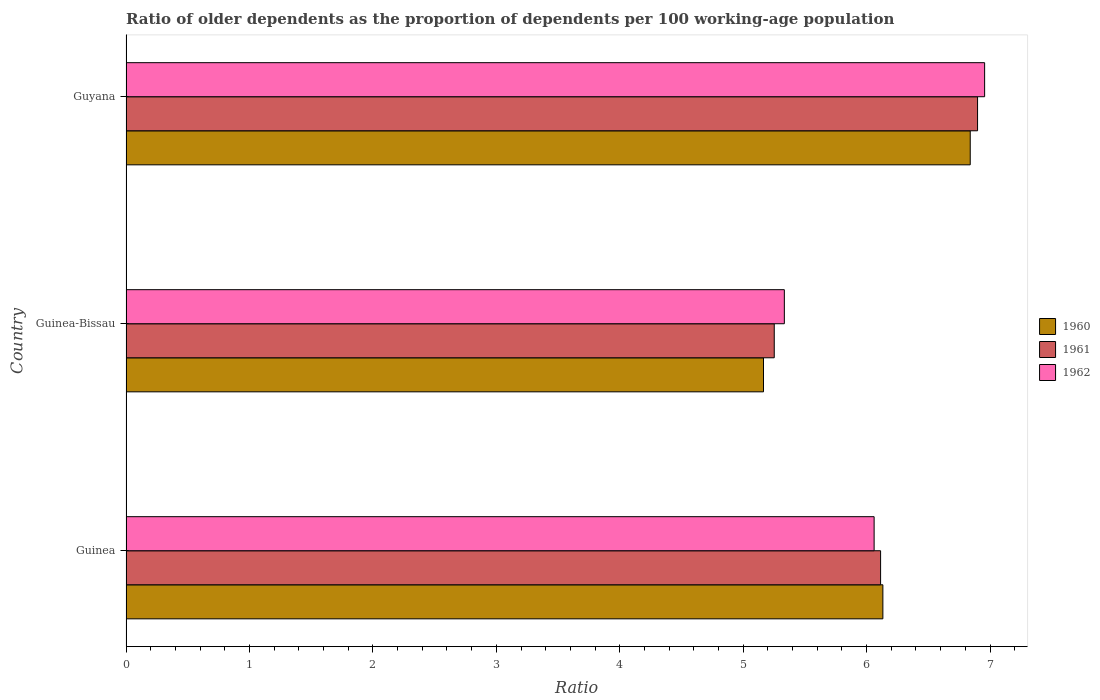How many groups of bars are there?
Your answer should be compact. 3. Are the number of bars per tick equal to the number of legend labels?
Make the answer very short. Yes. Are the number of bars on each tick of the Y-axis equal?
Your response must be concise. Yes. What is the label of the 2nd group of bars from the top?
Make the answer very short. Guinea-Bissau. In how many cases, is the number of bars for a given country not equal to the number of legend labels?
Provide a short and direct response. 0. What is the age dependency ratio(old) in 1962 in Guinea-Bissau?
Your response must be concise. 5.33. Across all countries, what is the maximum age dependency ratio(old) in 1961?
Ensure brevity in your answer.  6.9. Across all countries, what is the minimum age dependency ratio(old) in 1961?
Your answer should be very brief. 5.25. In which country was the age dependency ratio(old) in 1962 maximum?
Your answer should be very brief. Guyana. In which country was the age dependency ratio(old) in 1962 minimum?
Your response must be concise. Guinea-Bissau. What is the total age dependency ratio(old) in 1962 in the graph?
Give a very brief answer. 18.35. What is the difference between the age dependency ratio(old) in 1960 in Guinea and that in Guinea-Bissau?
Provide a short and direct response. 0.97. What is the difference between the age dependency ratio(old) in 1961 in Guinea-Bissau and the age dependency ratio(old) in 1962 in Guinea?
Give a very brief answer. -0.81. What is the average age dependency ratio(old) in 1961 per country?
Your response must be concise. 6.09. What is the difference between the age dependency ratio(old) in 1960 and age dependency ratio(old) in 1961 in Guinea?
Give a very brief answer. 0.02. What is the ratio of the age dependency ratio(old) in 1961 in Guinea-Bissau to that in Guyana?
Provide a succinct answer. 0.76. Is the age dependency ratio(old) in 1962 in Guinea less than that in Guinea-Bissau?
Make the answer very short. No. What is the difference between the highest and the second highest age dependency ratio(old) in 1960?
Provide a succinct answer. 0.71. What is the difference between the highest and the lowest age dependency ratio(old) in 1960?
Your answer should be very brief. 1.67. In how many countries, is the age dependency ratio(old) in 1961 greater than the average age dependency ratio(old) in 1961 taken over all countries?
Offer a very short reply. 2. What does the 3rd bar from the bottom in Guinea-Bissau represents?
Offer a very short reply. 1962. Is it the case that in every country, the sum of the age dependency ratio(old) in 1962 and age dependency ratio(old) in 1961 is greater than the age dependency ratio(old) in 1960?
Your answer should be compact. Yes. Are all the bars in the graph horizontal?
Keep it short and to the point. Yes. How many countries are there in the graph?
Your response must be concise. 3. What is the difference between two consecutive major ticks on the X-axis?
Offer a very short reply. 1. Does the graph contain any zero values?
Your response must be concise. No. Does the graph contain grids?
Make the answer very short. No. Where does the legend appear in the graph?
Offer a terse response. Center right. How are the legend labels stacked?
Provide a succinct answer. Vertical. What is the title of the graph?
Offer a very short reply. Ratio of older dependents as the proportion of dependents per 100 working-age population. Does "2000" appear as one of the legend labels in the graph?
Your answer should be compact. No. What is the label or title of the X-axis?
Give a very brief answer. Ratio. What is the label or title of the Y-axis?
Offer a very short reply. Country. What is the Ratio in 1960 in Guinea?
Your answer should be very brief. 6.13. What is the Ratio of 1961 in Guinea?
Ensure brevity in your answer.  6.11. What is the Ratio of 1962 in Guinea?
Your answer should be compact. 6.06. What is the Ratio in 1960 in Guinea-Bissau?
Offer a very short reply. 5.16. What is the Ratio of 1961 in Guinea-Bissau?
Provide a succinct answer. 5.25. What is the Ratio of 1962 in Guinea-Bissau?
Make the answer very short. 5.33. What is the Ratio in 1960 in Guyana?
Your answer should be very brief. 6.84. What is the Ratio in 1961 in Guyana?
Offer a terse response. 6.9. What is the Ratio in 1962 in Guyana?
Keep it short and to the point. 6.96. Across all countries, what is the maximum Ratio of 1960?
Your answer should be very brief. 6.84. Across all countries, what is the maximum Ratio in 1961?
Offer a terse response. 6.9. Across all countries, what is the maximum Ratio of 1962?
Your response must be concise. 6.96. Across all countries, what is the minimum Ratio of 1960?
Your answer should be very brief. 5.16. Across all countries, what is the minimum Ratio of 1961?
Give a very brief answer. 5.25. Across all countries, what is the minimum Ratio of 1962?
Give a very brief answer. 5.33. What is the total Ratio of 1960 in the graph?
Your response must be concise. 18.14. What is the total Ratio in 1961 in the graph?
Offer a very short reply. 18.26. What is the total Ratio of 1962 in the graph?
Ensure brevity in your answer.  18.35. What is the difference between the Ratio of 1960 in Guinea and that in Guinea-Bissau?
Provide a short and direct response. 0.97. What is the difference between the Ratio in 1961 in Guinea and that in Guinea-Bissau?
Offer a very short reply. 0.86. What is the difference between the Ratio of 1962 in Guinea and that in Guinea-Bissau?
Provide a short and direct response. 0.73. What is the difference between the Ratio of 1960 in Guinea and that in Guyana?
Keep it short and to the point. -0.71. What is the difference between the Ratio in 1961 in Guinea and that in Guyana?
Make the answer very short. -0.79. What is the difference between the Ratio in 1962 in Guinea and that in Guyana?
Keep it short and to the point. -0.9. What is the difference between the Ratio of 1960 in Guinea-Bissau and that in Guyana?
Your answer should be compact. -1.67. What is the difference between the Ratio of 1961 in Guinea-Bissau and that in Guyana?
Provide a succinct answer. -1.65. What is the difference between the Ratio in 1962 in Guinea-Bissau and that in Guyana?
Provide a succinct answer. -1.62. What is the difference between the Ratio of 1960 in Guinea and the Ratio of 1961 in Guinea-Bissau?
Your answer should be compact. 0.88. What is the difference between the Ratio in 1960 in Guinea and the Ratio in 1962 in Guinea-Bissau?
Provide a succinct answer. 0.8. What is the difference between the Ratio in 1961 in Guinea and the Ratio in 1962 in Guinea-Bissau?
Offer a very short reply. 0.78. What is the difference between the Ratio in 1960 in Guinea and the Ratio in 1961 in Guyana?
Your answer should be compact. -0.77. What is the difference between the Ratio in 1960 in Guinea and the Ratio in 1962 in Guyana?
Provide a succinct answer. -0.82. What is the difference between the Ratio of 1961 in Guinea and the Ratio of 1962 in Guyana?
Make the answer very short. -0.84. What is the difference between the Ratio in 1960 in Guinea-Bissau and the Ratio in 1961 in Guyana?
Offer a terse response. -1.73. What is the difference between the Ratio of 1960 in Guinea-Bissau and the Ratio of 1962 in Guyana?
Provide a short and direct response. -1.79. What is the difference between the Ratio in 1961 in Guinea-Bissau and the Ratio in 1962 in Guyana?
Provide a short and direct response. -1.7. What is the average Ratio in 1960 per country?
Make the answer very short. 6.05. What is the average Ratio in 1961 per country?
Your answer should be very brief. 6.09. What is the average Ratio in 1962 per country?
Your answer should be very brief. 6.12. What is the difference between the Ratio in 1960 and Ratio in 1961 in Guinea?
Offer a terse response. 0.02. What is the difference between the Ratio in 1960 and Ratio in 1962 in Guinea?
Your answer should be very brief. 0.07. What is the difference between the Ratio in 1961 and Ratio in 1962 in Guinea?
Provide a short and direct response. 0.05. What is the difference between the Ratio of 1960 and Ratio of 1961 in Guinea-Bissau?
Offer a very short reply. -0.09. What is the difference between the Ratio of 1960 and Ratio of 1962 in Guinea-Bissau?
Your answer should be very brief. -0.17. What is the difference between the Ratio of 1961 and Ratio of 1962 in Guinea-Bissau?
Your response must be concise. -0.08. What is the difference between the Ratio of 1960 and Ratio of 1961 in Guyana?
Give a very brief answer. -0.06. What is the difference between the Ratio in 1960 and Ratio in 1962 in Guyana?
Provide a short and direct response. -0.12. What is the difference between the Ratio in 1961 and Ratio in 1962 in Guyana?
Provide a short and direct response. -0.06. What is the ratio of the Ratio in 1960 in Guinea to that in Guinea-Bissau?
Make the answer very short. 1.19. What is the ratio of the Ratio of 1961 in Guinea to that in Guinea-Bissau?
Ensure brevity in your answer.  1.16. What is the ratio of the Ratio of 1962 in Guinea to that in Guinea-Bissau?
Give a very brief answer. 1.14. What is the ratio of the Ratio in 1960 in Guinea to that in Guyana?
Make the answer very short. 0.9. What is the ratio of the Ratio of 1961 in Guinea to that in Guyana?
Offer a terse response. 0.89. What is the ratio of the Ratio of 1962 in Guinea to that in Guyana?
Make the answer very short. 0.87. What is the ratio of the Ratio in 1960 in Guinea-Bissau to that in Guyana?
Give a very brief answer. 0.76. What is the ratio of the Ratio in 1961 in Guinea-Bissau to that in Guyana?
Your answer should be very brief. 0.76. What is the ratio of the Ratio of 1962 in Guinea-Bissau to that in Guyana?
Make the answer very short. 0.77. What is the difference between the highest and the second highest Ratio in 1960?
Make the answer very short. 0.71. What is the difference between the highest and the second highest Ratio in 1961?
Provide a succinct answer. 0.79. What is the difference between the highest and the second highest Ratio of 1962?
Make the answer very short. 0.9. What is the difference between the highest and the lowest Ratio in 1960?
Your response must be concise. 1.67. What is the difference between the highest and the lowest Ratio of 1961?
Your response must be concise. 1.65. What is the difference between the highest and the lowest Ratio of 1962?
Provide a succinct answer. 1.62. 